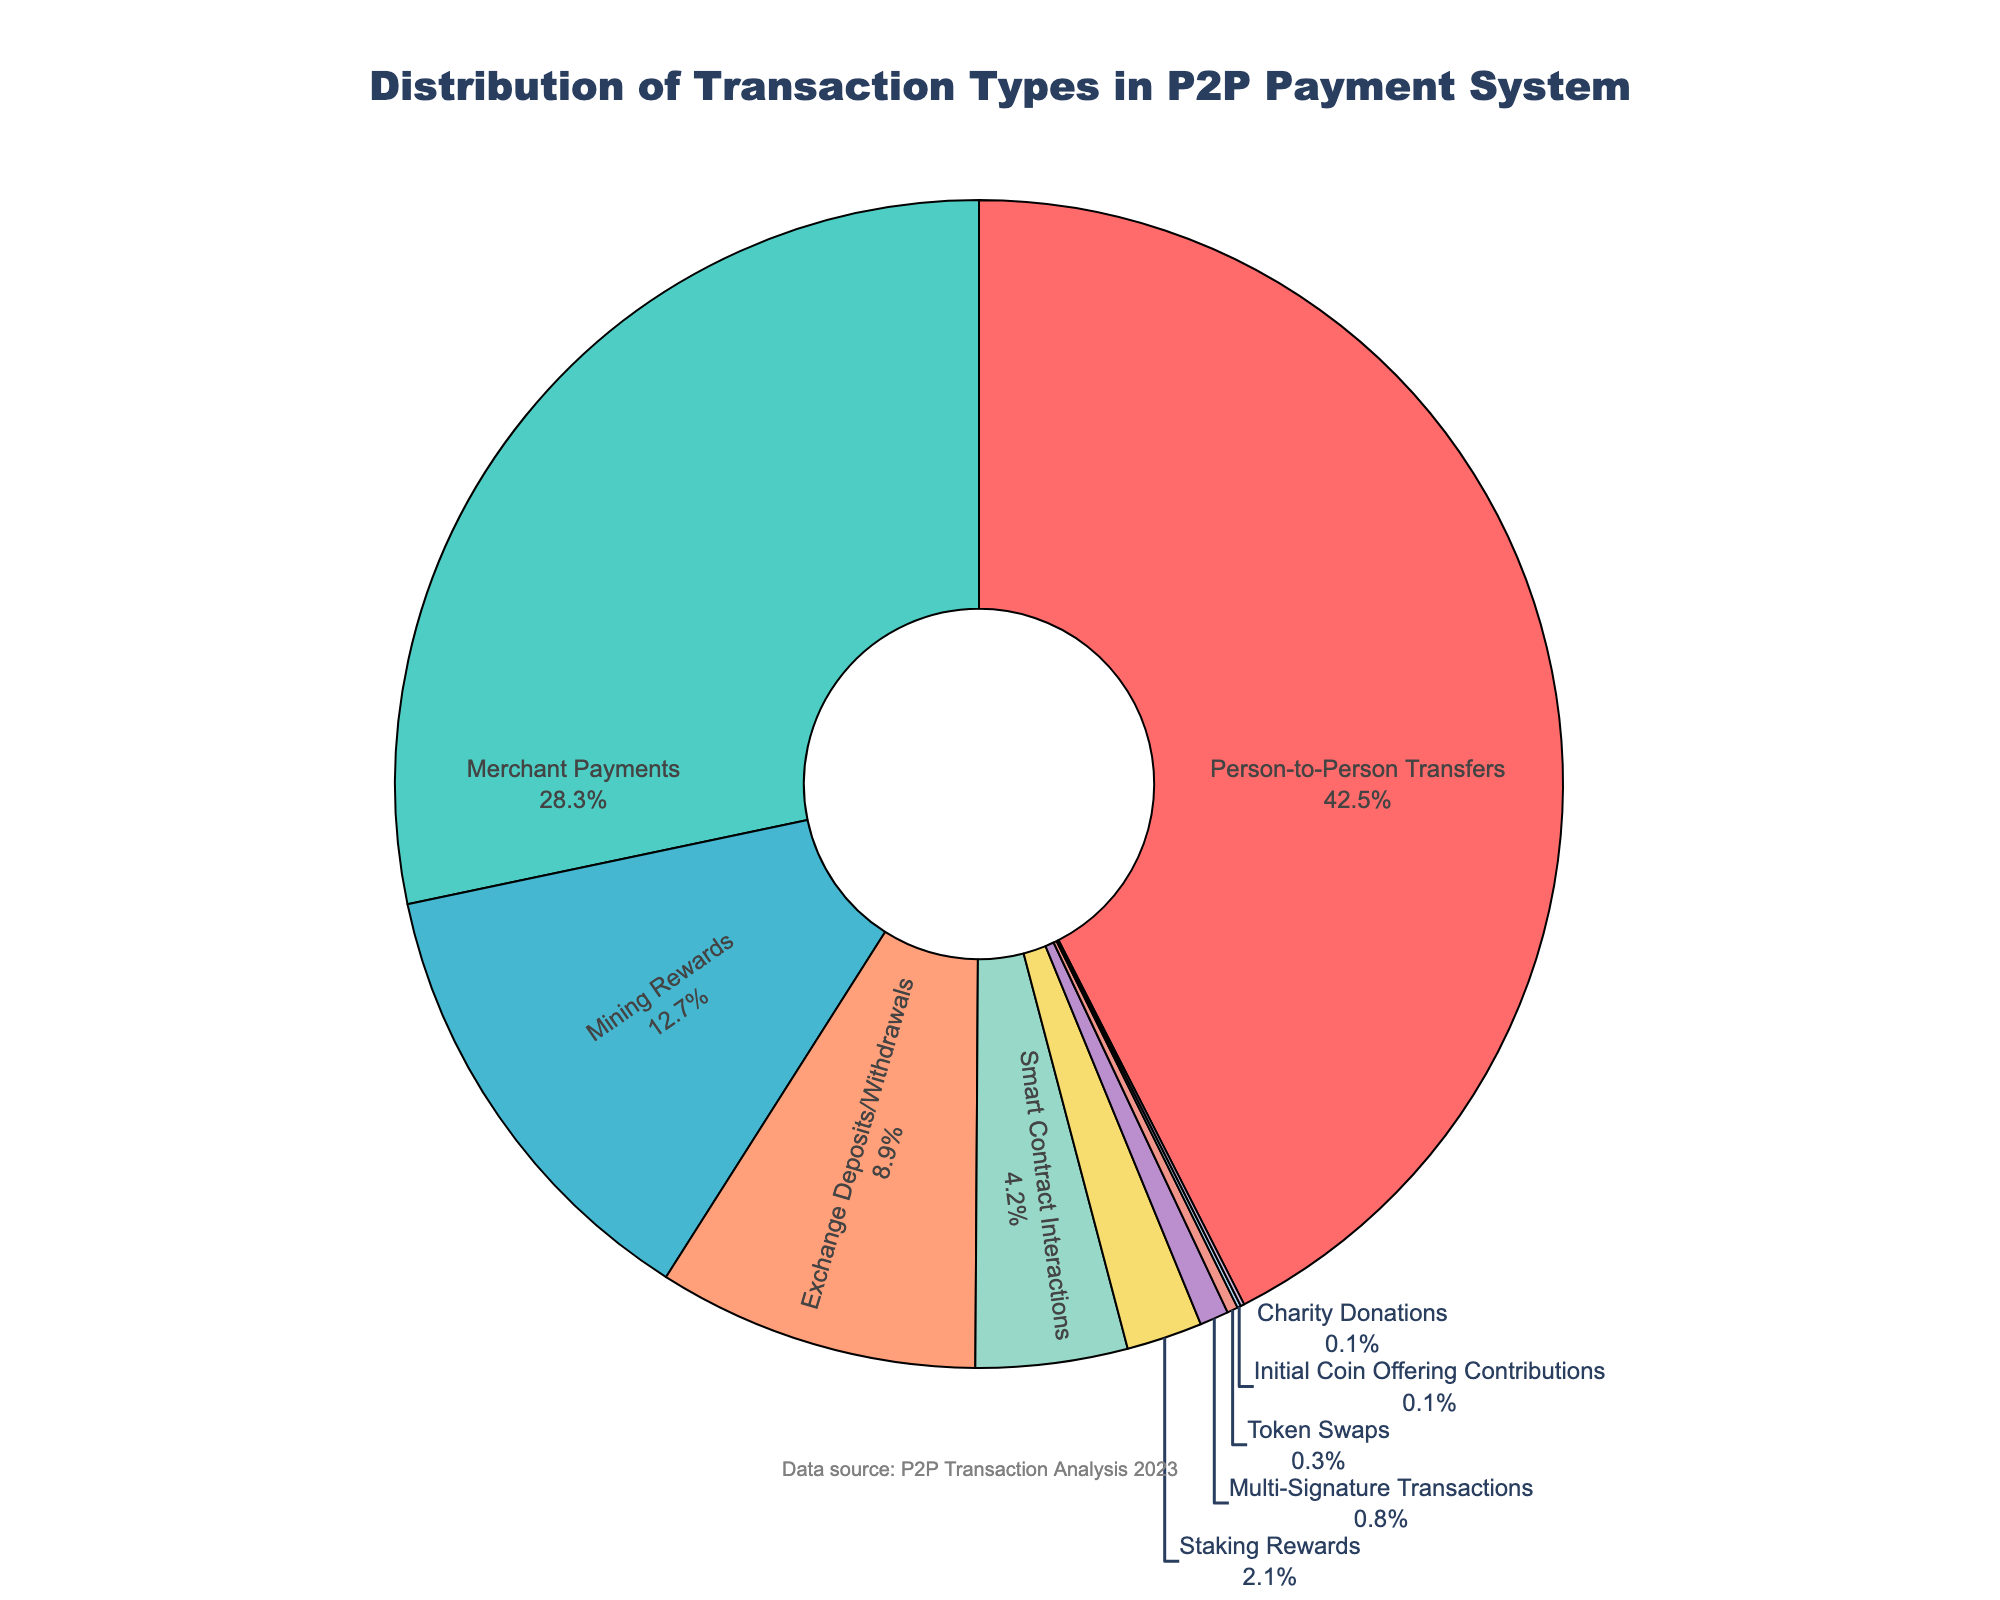What is the most common type of transaction in the system? The most common type of transaction is the one with the highest percentage in the pie chart, which is Person-to-Person Transfers at 42.5%.
Answer: Person-to-Person Transfers Which transaction type has a higher percentage: Merchant Payments or Mining Rewards? To determine which type has a higher percentage, compare the percentages. Merchant Payments have 28.3% and Mining Rewards have 12.7%. Merchant Payments have a higher percentage.
Answer: Merchant Payments What is the total percentage of transactions related to rewards (Mining Rewards and Staking Rewards combined)? Add the percentages of Mining Rewards (12.7%) and Staking Rewards (2.1%). 12.7% + 2.1% = 14.8%.
Answer: 14.8% How much more common are Exchange Deposits/Withdrawals than Initial Coin Offering Contributions? Subtract the percentage of Initial Coin Offering Contributions (0.1%) from Exchange Deposits/Withdrawals (8.9%). 8.9% - 0.1% = 8.8%.
Answer: 8.8% Are there more Merchant Payments or Multi-Signature Transactions? Compare the percentages of Merchant Payments (28.3%) and Multi-Signature Transactions (0.8%). Merchant Payments are more common.
Answer: Merchant Payments What percentage of transactions are categorized as Token Swaps and Charity Donations combined? Add the percentages of Token Swaps (0.3%) and Charity Donations (0.1%). 0.3% + 0.1% = 0.4%.
Answer: 0.4% Which transaction type is represented by the color red in the pie chart? Match the color red to its corresponding data point in the pie chart. In the given configuration, red represents Person-to-Person Transfers.
Answer: Person-to-Person Transfers Which type of transaction is less common: Smart Contract Interactions or Staking Rewards? Compare the percentages of Smart Contract Interactions (4.2%) and Staking Rewards (2.1%). Staking Rewards are less common.
Answer: Staking Rewards 